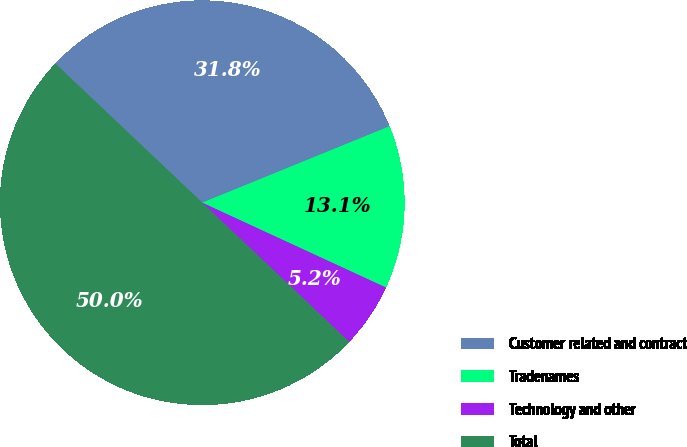<chart> <loc_0><loc_0><loc_500><loc_500><pie_chart><fcel>Customer related and contract<fcel>Tradenames<fcel>Technology and other<fcel>Total<nl><fcel>31.77%<fcel>13.05%<fcel>5.18%<fcel>50.0%<nl></chart> 